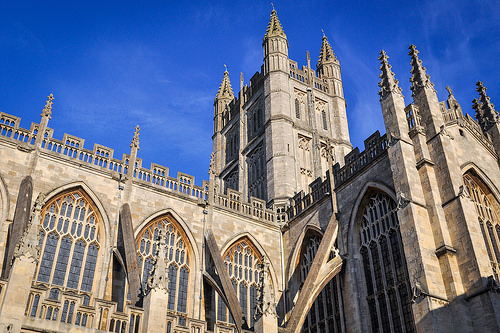<image>
Is there a church under the sky? Yes. The church is positioned underneath the sky, with the sky above it in the vertical space. 